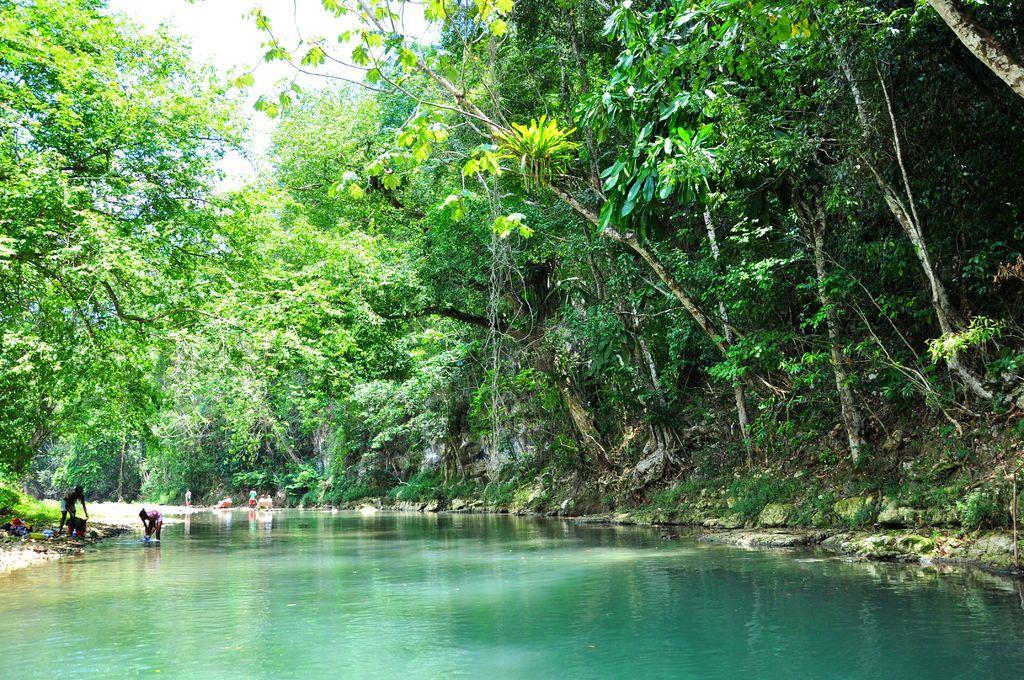Can you describe this image briefly? In the image there is a canal in the middle with trees on either side of it, in the back there are few persons washing clothes in the canal. 